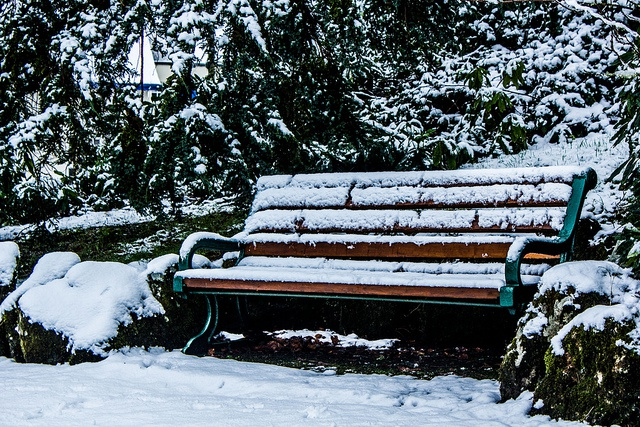Describe the objects in this image and their specific colors. I can see a bench in teal, black, lavender, lightblue, and maroon tones in this image. 